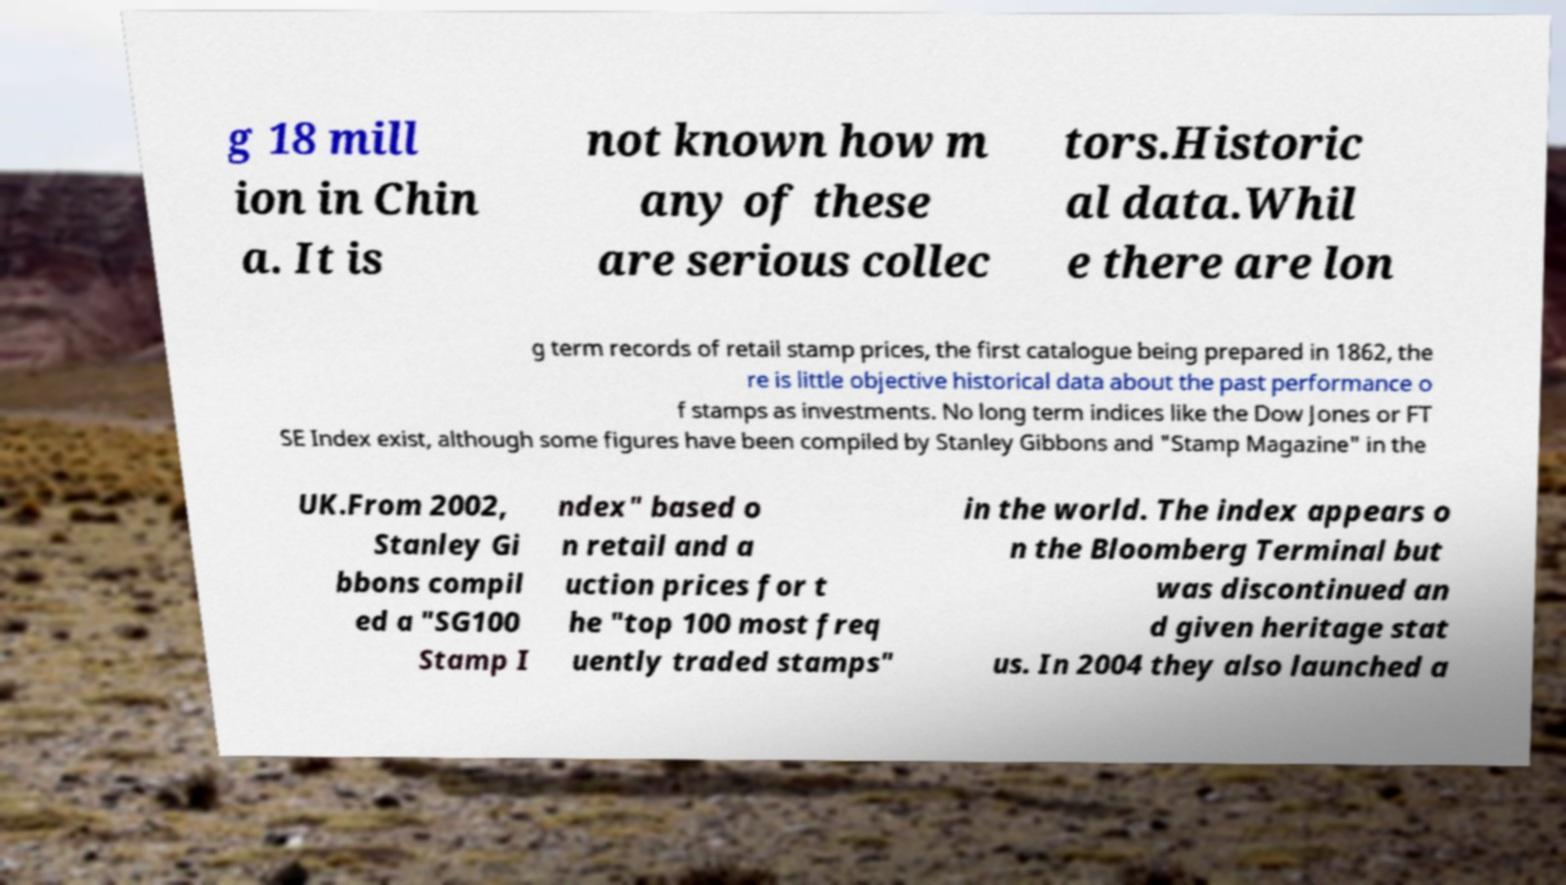What messages or text are displayed in this image? I need them in a readable, typed format. g 18 mill ion in Chin a. It is not known how m any of these are serious collec tors.Historic al data.Whil e there are lon g term records of retail stamp prices, the first catalogue being prepared in 1862, the re is little objective historical data about the past performance o f stamps as investments. No long term indices like the Dow Jones or FT SE Index exist, although some figures have been compiled by Stanley Gibbons and "Stamp Magazine" in the UK.From 2002, Stanley Gi bbons compil ed a "SG100 Stamp I ndex" based o n retail and a uction prices for t he "top 100 most freq uently traded stamps" in the world. The index appears o n the Bloomberg Terminal but was discontinued an d given heritage stat us. In 2004 they also launched a 